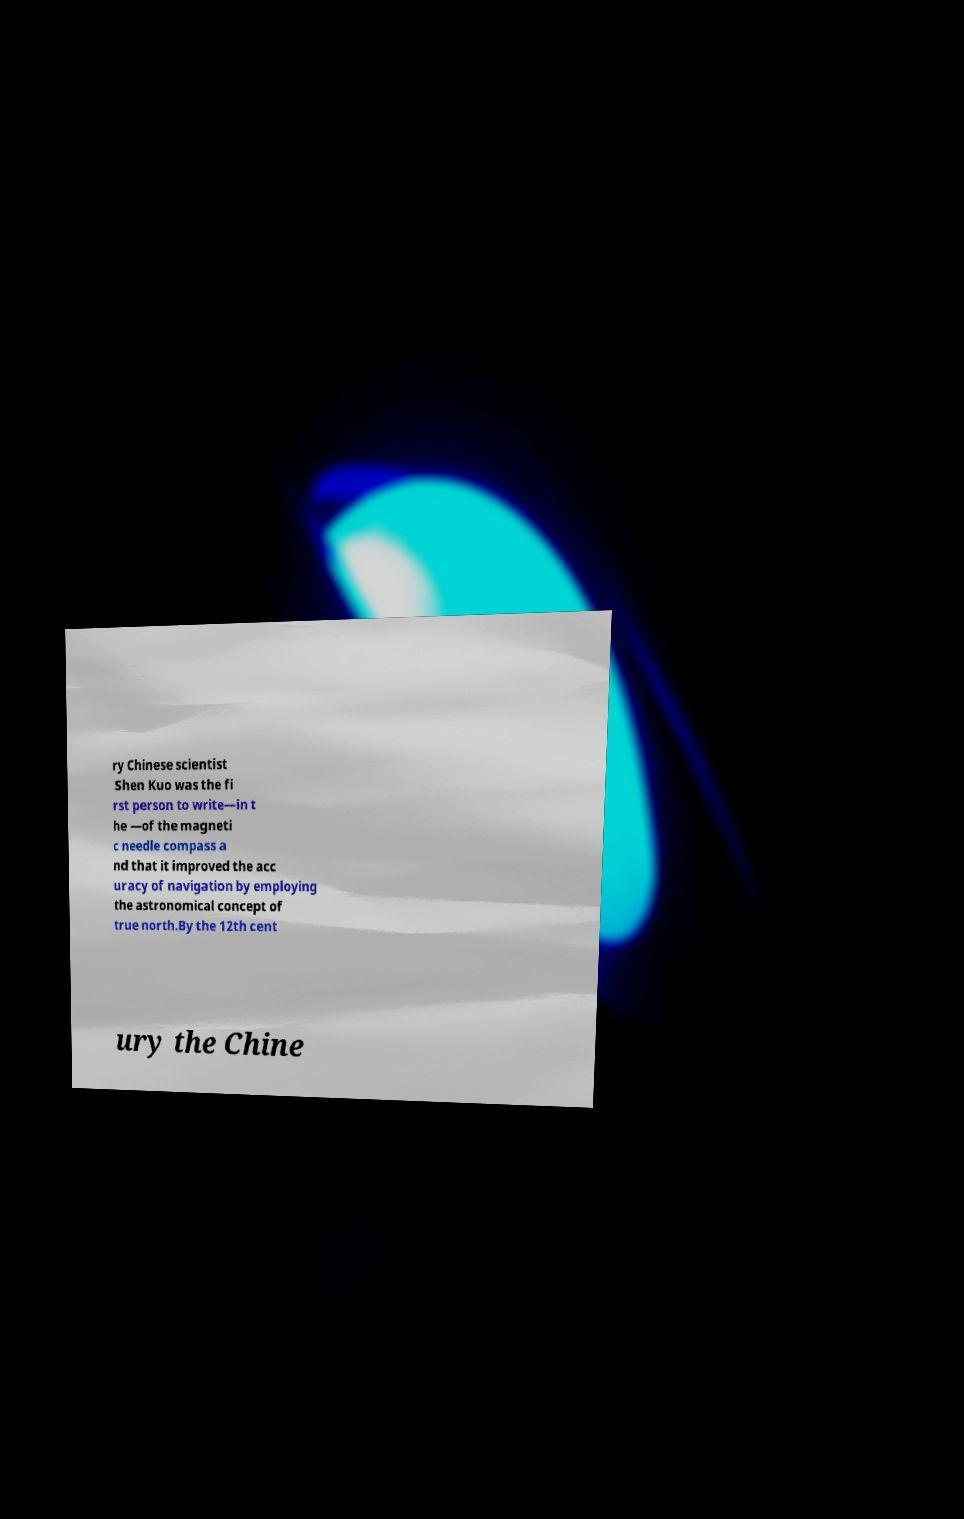Please read and relay the text visible in this image. What does it say? ry Chinese scientist Shen Kuo was the fi rst person to write—in t he —of the magneti c needle compass a nd that it improved the acc uracy of navigation by employing the astronomical concept of true north.By the 12th cent ury the Chine 